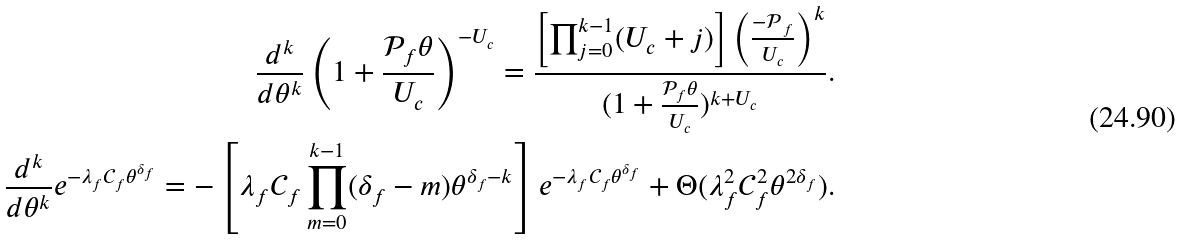<formula> <loc_0><loc_0><loc_500><loc_500>\frac { d ^ { k } } { d \theta ^ { k } } \left ( 1 + \frac { \mathcal { P } _ { f } \theta } { U _ { c } } \right ) ^ { - U _ { c } } = \frac { \left [ \prod _ { j = 0 } ^ { k - 1 } ( U _ { c } + j ) \right ] \left ( \frac { \mathcal { - P } _ { f } } { U _ { c } } \right ) ^ { k } } { ( 1 + \frac { \mathcal { P } _ { f } \theta } { U _ { c } } ) ^ { k + U _ { c } } } . \\ \frac { d ^ { k } } { d \theta ^ { k } } e ^ { - \lambda _ { f } \mathcal { C } _ { f } \theta ^ { \delta _ { f } } } = - \left [ \lambda _ { f } \mathcal { C } _ { f } \prod _ { m = 0 } ^ { k - 1 } ( \delta _ { f } - m ) \theta ^ { \delta _ { f } - k } \right ] e ^ { - \lambda _ { f } \mathcal { C } _ { f } \theta ^ { \delta _ { f } } } + \Theta ( \lambda _ { f } ^ { 2 } \mathcal { C } _ { f } ^ { 2 } \theta ^ { 2 \delta _ { f } } ) .</formula> 